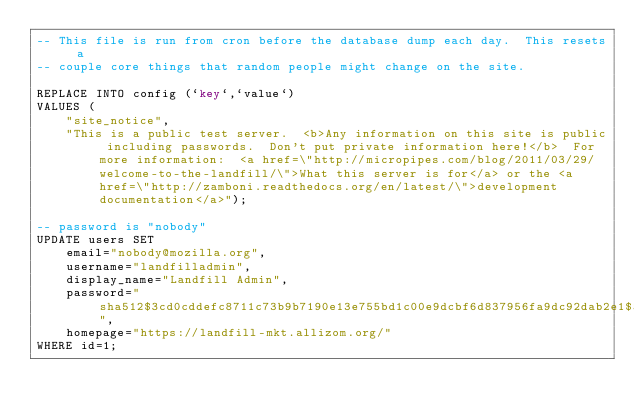Convert code to text. <code><loc_0><loc_0><loc_500><loc_500><_SQL_>-- This file is run from cron before the database dump each day.  This resets a
-- couple core things that random people might change on the site.

REPLACE INTO config (`key`,`value`) 
VALUES (
    "site_notice",
    "This is a public test server.  <b>Any information on this site is public including passwords.  Don't put private information here!</b>  For more information:  <a href=\"http://micropipes.com/blog/2011/03/29/welcome-to-the-landfill/\">What this server is for</a> or the <a href=\"http://zamboni.readthedocs.org/en/latest/\">development documentation</a>");

-- password is "nobody"
UPDATE users SET 
    email="nobody@mozilla.org",
    username="landfilladmin",
    display_name="Landfill Admin",
    password="sha512$3cd0cddefc8711c73b9b7190e13e755bd1c00e9dcbf6d837956fa9dc92dab2e1$5669268c0f604520f13b5b956580bf137914df81f99702b77d462ac24f7b63e60611560ee754ad729674149543d11e54d7596453d9a739c40a0a5a4ca4b062e1",
    homepage="https://landfill-mkt.allizom.org/"
WHERE id=1;
</code> 